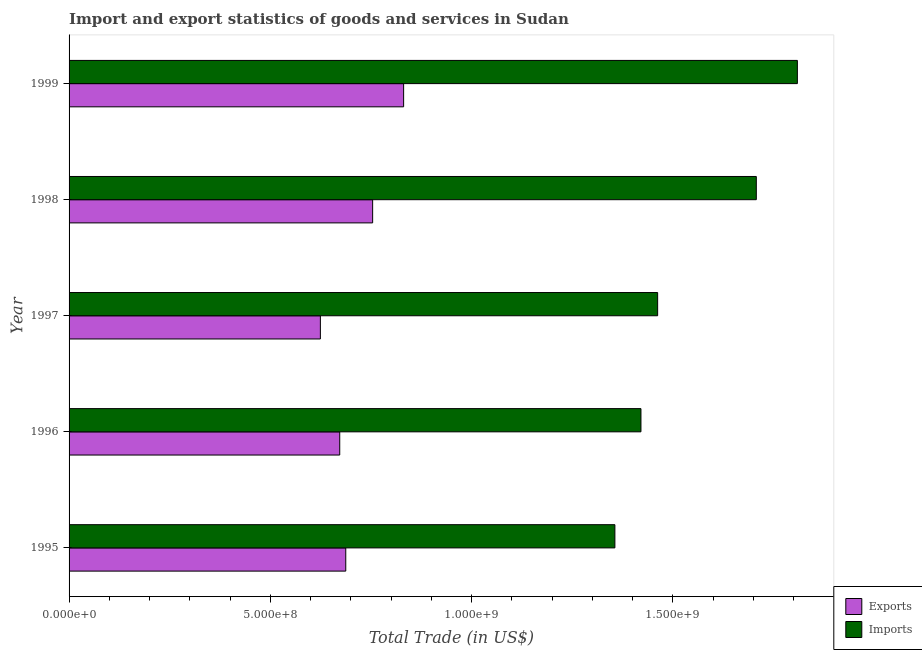How many groups of bars are there?
Ensure brevity in your answer.  5. Are the number of bars per tick equal to the number of legend labels?
Your answer should be compact. Yes. Are the number of bars on each tick of the Y-axis equal?
Your answer should be compact. Yes. What is the export of goods and services in 1998?
Your response must be concise. 7.54e+08. Across all years, what is the maximum imports of goods and services?
Provide a short and direct response. 1.81e+09. Across all years, what is the minimum imports of goods and services?
Make the answer very short. 1.36e+09. In which year was the export of goods and services maximum?
Give a very brief answer. 1999. What is the total export of goods and services in the graph?
Your answer should be compact. 3.57e+09. What is the difference between the export of goods and services in 1995 and that in 1999?
Your answer should be very brief. -1.44e+08. What is the difference between the imports of goods and services in 1999 and the export of goods and services in 1995?
Offer a terse response. 1.12e+09. What is the average imports of goods and services per year?
Your answer should be compact. 1.55e+09. In the year 1998, what is the difference between the imports of goods and services and export of goods and services?
Provide a short and direct response. 9.53e+08. In how many years, is the imports of goods and services greater than 400000000 US$?
Your answer should be compact. 5. What is the ratio of the export of goods and services in 1995 to that in 1999?
Keep it short and to the point. 0.83. Is the imports of goods and services in 1997 less than that in 1999?
Your answer should be compact. Yes. Is the difference between the imports of goods and services in 1996 and 1999 greater than the difference between the export of goods and services in 1996 and 1999?
Your response must be concise. No. What is the difference between the highest and the second highest export of goods and services?
Provide a short and direct response. 7.70e+07. What is the difference between the highest and the lowest export of goods and services?
Keep it short and to the point. 2.07e+08. What does the 1st bar from the top in 1995 represents?
Provide a succinct answer. Imports. What does the 1st bar from the bottom in 1995 represents?
Your response must be concise. Exports. Are all the bars in the graph horizontal?
Offer a terse response. Yes. How many years are there in the graph?
Your answer should be compact. 5. Does the graph contain any zero values?
Your answer should be very brief. No. What is the title of the graph?
Your answer should be very brief. Import and export statistics of goods and services in Sudan. What is the label or title of the X-axis?
Your response must be concise. Total Trade (in US$). What is the label or title of the Y-axis?
Your answer should be very brief. Year. What is the Total Trade (in US$) of Exports in 1995?
Your answer should be compact. 6.87e+08. What is the Total Trade (in US$) in Imports in 1995?
Make the answer very short. 1.36e+09. What is the Total Trade (in US$) of Exports in 1996?
Give a very brief answer. 6.72e+08. What is the Total Trade (in US$) in Imports in 1996?
Make the answer very short. 1.42e+09. What is the Total Trade (in US$) in Exports in 1997?
Give a very brief answer. 6.24e+08. What is the Total Trade (in US$) of Imports in 1997?
Your answer should be compact. 1.46e+09. What is the Total Trade (in US$) in Exports in 1998?
Provide a short and direct response. 7.54e+08. What is the Total Trade (in US$) in Imports in 1998?
Offer a very short reply. 1.71e+09. What is the Total Trade (in US$) in Exports in 1999?
Make the answer very short. 8.31e+08. What is the Total Trade (in US$) of Imports in 1999?
Your answer should be very brief. 1.81e+09. Across all years, what is the maximum Total Trade (in US$) in Exports?
Give a very brief answer. 8.31e+08. Across all years, what is the maximum Total Trade (in US$) in Imports?
Your response must be concise. 1.81e+09. Across all years, what is the minimum Total Trade (in US$) in Exports?
Make the answer very short. 6.24e+08. Across all years, what is the minimum Total Trade (in US$) of Imports?
Your answer should be compact. 1.36e+09. What is the total Total Trade (in US$) of Exports in the graph?
Ensure brevity in your answer.  3.57e+09. What is the total Total Trade (in US$) in Imports in the graph?
Your answer should be compact. 7.75e+09. What is the difference between the Total Trade (in US$) of Exports in 1995 and that in 1996?
Offer a terse response. 1.50e+07. What is the difference between the Total Trade (in US$) in Imports in 1995 and that in 1996?
Provide a succinct answer. -6.48e+07. What is the difference between the Total Trade (in US$) of Exports in 1995 and that in 1997?
Give a very brief answer. 6.30e+07. What is the difference between the Total Trade (in US$) in Imports in 1995 and that in 1997?
Your response must be concise. -1.06e+08. What is the difference between the Total Trade (in US$) of Exports in 1995 and that in 1998?
Provide a short and direct response. -6.67e+07. What is the difference between the Total Trade (in US$) in Imports in 1995 and that in 1998?
Provide a succinct answer. -3.51e+08. What is the difference between the Total Trade (in US$) of Exports in 1995 and that in 1999?
Ensure brevity in your answer.  -1.44e+08. What is the difference between the Total Trade (in US$) in Imports in 1995 and that in 1999?
Offer a terse response. -4.53e+08. What is the difference between the Total Trade (in US$) of Exports in 1996 and that in 1997?
Your response must be concise. 4.81e+07. What is the difference between the Total Trade (in US$) in Imports in 1996 and that in 1997?
Provide a succinct answer. -4.14e+07. What is the difference between the Total Trade (in US$) in Exports in 1996 and that in 1998?
Offer a very short reply. -8.17e+07. What is the difference between the Total Trade (in US$) of Imports in 1996 and that in 1998?
Your answer should be very brief. -2.87e+08. What is the difference between the Total Trade (in US$) in Exports in 1996 and that in 1999?
Your answer should be compact. -1.59e+08. What is the difference between the Total Trade (in US$) of Imports in 1996 and that in 1999?
Offer a very short reply. -3.89e+08. What is the difference between the Total Trade (in US$) of Exports in 1997 and that in 1998?
Provide a succinct answer. -1.30e+08. What is the difference between the Total Trade (in US$) of Imports in 1997 and that in 1998?
Your answer should be very brief. -2.45e+08. What is the difference between the Total Trade (in US$) in Exports in 1997 and that in 1999?
Keep it short and to the point. -2.07e+08. What is the difference between the Total Trade (in US$) in Imports in 1997 and that in 1999?
Make the answer very short. -3.47e+08. What is the difference between the Total Trade (in US$) in Exports in 1998 and that in 1999?
Offer a terse response. -7.70e+07. What is the difference between the Total Trade (in US$) in Imports in 1998 and that in 1999?
Your response must be concise. -1.02e+08. What is the difference between the Total Trade (in US$) of Exports in 1995 and the Total Trade (in US$) of Imports in 1996?
Make the answer very short. -7.33e+08. What is the difference between the Total Trade (in US$) of Exports in 1995 and the Total Trade (in US$) of Imports in 1997?
Your answer should be compact. -7.75e+08. What is the difference between the Total Trade (in US$) in Exports in 1995 and the Total Trade (in US$) in Imports in 1998?
Make the answer very short. -1.02e+09. What is the difference between the Total Trade (in US$) of Exports in 1995 and the Total Trade (in US$) of Imports in 1999?
Your response must be concise. -1.12e+09. What is the difference between the Total Trade (in US$) in Exports in 1996 and the Total Trade (in US$) in Imports in 1997?
Your answer should be very brief. -7.90e+08. What is the difference between the Total Trade (in US$) in Exports in 1996 and the Total Trade (in US$) in Imports in 1998?
Your response must be concise. -1.03e+09. What is the difference between the Total Trade (in US$) of Exports in 1996 and the Total Trade (in US$) of Imports in 1999?
Offer a terse response. -1.14e+09. What is the difference between the Total Trade (in US$) of Exports in 1997 and the Total Trade (in US$) of Imports in 1998?
Offer a very short reply. -1.08e+09. What is the difference between the Total Trade (in US$) of Exports in 1997 and the Total Trade (in US$) of Imports in 1999?
Give a very brief answer. -1.18e+09. What is the difference between the Total Trade (in US$) of Exports in 1998 and the Total Trade (in US$) of Imports in 1999?
Provide a short and direct response. -1.05e+09. What is the average Total Trade (in US$) of Exports per year?
Your answer should be compact. 7.14e+08. What is the average Total Trade (in US$) in Imports per year?
Keep it short and to the point. 1.55e+09. In the year 1995, what is the difference between the Total Trade (in US$) of Exports and Total Trade (in US$) of Imports?
Offer a very short reply. -6.68e+08. In the year 1996, what is the difference between the Total Trade (in US$) in Exports and Total Trade (in US$) in Imports?
Give a very brief answer. -7.48e+08. In the year 1997, what is the difference between the Total Trade (in US$) of Exports and Total Trade (in US$) of Imports?
Keep it short and to the point. -8.38e+08. In the year 1998, what is the difference between the Total Trade (in US$) in Exports and Total Trade (in US$) in Imports?
Your answer should be very brief. -9.53e+08. In the year 1999, what is the difference between the Total Trade (in US$) in Exports and Total Trade (in US$) in Imports?
Keep it short and to the point. -9.78e+08. What is the ratio of the Total Trade (in US$) of Exports in 1995 to that in 1996?
Keep it short and to the point. 1.02. What is the ratio of the Total Trade (in US$) in Imports in 1995 to that in 1996?
Make the answer very short. 0.95. What is the ratio of the Total Trade (in US$) of Exports in 1995 to that in 1997?
Provide a short and direct response. 1.1. What is the ratio of the Total Trade (in US$) in Imports in 1995 to that in 1997?
Offer a very short reply. 0.93. What is the ratio of the Total Trade (in US$) in Exports in 1995 to that in 1998?
Offer a very short reply. 0.91. What is the ratio of the Total Trade (in US$) in Imports in 1995 to that in 1998?
Offer a very short reply. 0.79. What is the ratio of the Total Trade (in US$) of Exports in 1995 to that in 1999?
Offer a terse response. 0.83. What is the ratio of the Total Trade (in US$) in Imports in 1995 to that in 1999?
Provide a succinct answer. 0.75. What is the ratio of the Total Trade (in US$) of Exports in 1996 to that in 1997?
Your response must be concise. 1.08. What is the ratio of the Total Trade (in US$) in Imports in 1996 to that in 1997?
Make the answer very short. 0.97. What is the ratio of the Total Trade (in US$) in Exports in 1996 to that in 1998?
Keep it short and to the point. 0.89. What is the ratio of the Total Trade (in US$) in Imports in 1996 to that in 1998?
Your answer should be very brief. 0.83. What is the ratio of the Total Trade (in US$) of Exports in 1996 to that in 1999?
Your answer should be very brief. 0.81. What is the ratio of the Total Trade (in US$) in Imports in 1996 to that in 1999?
Provide a short and direct response. 0.79. What is the ratio of the Total Trade (in US$) of Exports in 1997 to that in 1998?
Your answer should be very brief. 0.83. What is the ratio of the Total Trade (in US$) of Imports in 1997 to that in 1998?
Offer a very short reply. 0.86. What is the ratio of the Total Trade (in US$) in Exports in 1997 to that in 1999?
Your answer should be compact. 0.75. What is the ratio of the Total Trade (in US$) of Imports in 1997 to that in 1999?
Your response must be concise. 0.81. What is the ratio of the Total Trade (in US$) in Exports in 1998 to that in 1999?
Your answer should be compact. 0.91. What is the ratio of the Total Trade (in US$) of Imports in 1998 to that in 1999?
Your answer should be very brief. 0.94. What is the difference between the highest and the second highest Total Trade (in US$) of Exports?
Provide a short and direct response. 7.70e+07. What is the difference between the highest and the second highest Total Trade (in US$) of Imports?
Offer a very short reply. 1.02e+08. What is the difference between the highest and the lowest Total Trade (in US$) of Exports?
Your answer should be compact. 2.07e+08. What is the difference between the highest and the lowest Total Trade (in US$) in Imports?
Keep it short and to the point. 4.53e+08. 